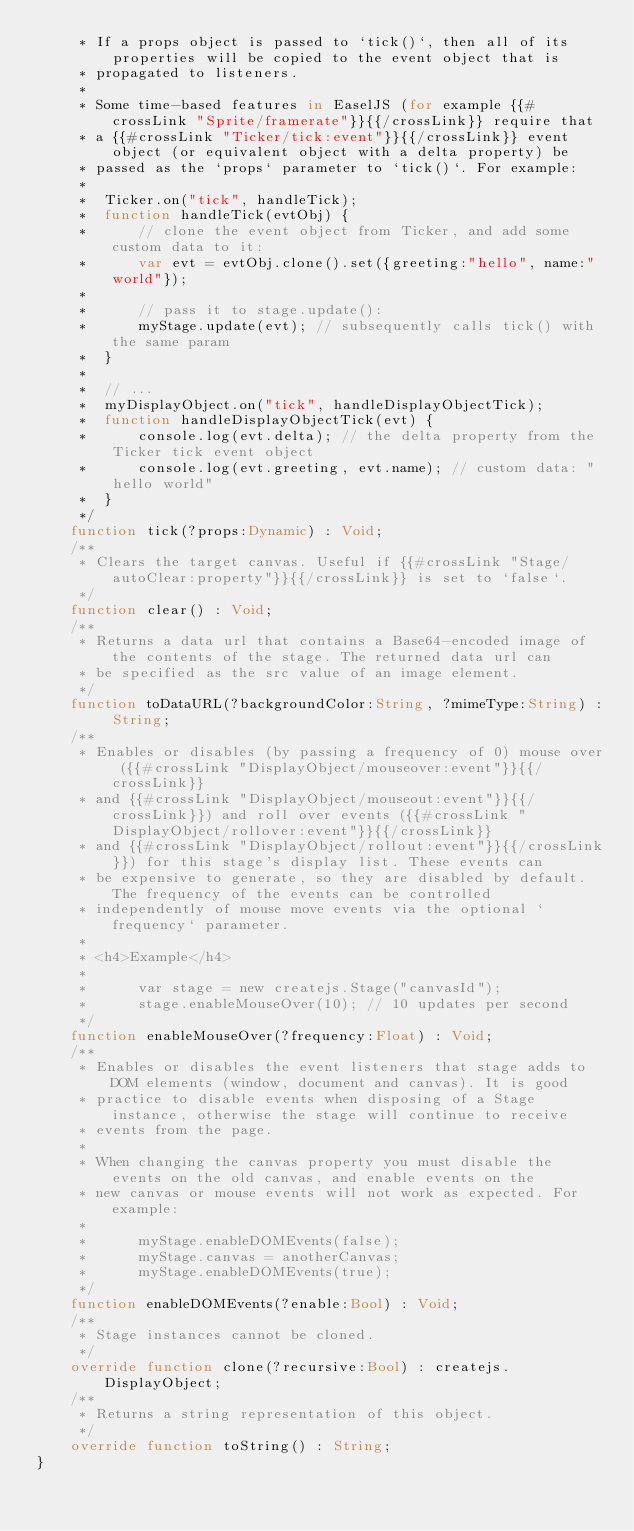<code> <loc_0><loc_0><loc_500><loc_500><_Haxe_>	 * If a props object is passed to `tick()`, then all of its properties will be copied to the event object that is
	 * propagated to listeners.
	 *
	 * Some time-based features in EaselJS (for example {{#crossLink "Sprite/framerate"}}{{/crossLink}} require that
	 * a {{#crossLink "Ticker/tick:event"}}{{/crossLink}} event object (or equivalent object with a delta property) be
	 * passed as the `props` parameter to `tick()`. For example:
	 *
	 * 	Ticker.on("tick", handleTick);
	 * 	function handleTick(evtObj) {
	 * 		// clone the event object from Ticker, and add some custom data to it:
	 * 		var evt = evtObj.clone().set({greeting:"hello", name:"world"});
	 *
	 * 		// pass it to stage.update():
	 * 		myStage.update(evt); // subsequently calls tick() with the same param
	 * 	}
	 *
	 * 	// ...
	 * 	myDisplayObject.on("tick", handleDisplayObjectTick);
	 * 	function handleDisplayObjectTick(evt) {
	 * 		console.log(evt.delta); // the delta property from the Ticker tick event object
	 * 		console.log(evt.greeting, evt.name); // custom data: "hello world"
	 * 	}
	 */
	function tick(?props:Dynamic) : Void;
	/**
	 * Clears the target canvas. Useful if {{#crossLink "Stage/autoClear:property"}}{{/crossLink}} is set to `false`.
	 */
	function clear() : Void;
	/**
	 * Returns a data url that contains a Base64-encoded image of the contents of the stage. The returned data url can
	 * be specified as the src value of an image element.
	 */
	function toDataURL(?backgroundColor:String, ?mimeType:String) : String;
	/**
	 * Enables or disables (by passing a frequency of 0) mouse over ({{#crossLink "DisplayObject/mouseover:event"}}{{/crossLink}}
	 * and {{#crossLink "DisplayObject/mouseout:event"}}{{/crossLink}}) and roll over events ({{#crossLink "DisplayObject/rollover:event"}}{{/crossLink}}
	 * and {{#crossLink "DisplayObject/rollout:event"}}{{/crossLink}}) for this stage's display list. These events can
	 * be expensive to generate, so they are disabled by default. The frequency of the events can be controlled
	 * independently of mouse move events via the optional `frequency` parameter.
	 *
	 * <h4>Example</h4>
	 *
	 *      var stage = new createjs.Stage("canvasId");
	 *      stage.enableMouseOver(10); // 10 updates per second
	 */
	function enableMouseOver(?frequency:Float) : Void;
	/**
	 * Enables or disables the event listeners that stage adds to DOM elements (window, document and canvas). It is good
	 * practice to disable events when disposing of a Stage instance, otherwise the stage will continue to receive
	 * events from the page.
	 *
	 * When changing the canvas property you must disable the events on the old canvas, and enable events on the
	 * new canvas or mouse events will not work as expected. For example:
	 *
	 *      myStage.enableDOMEvents(false);
	 *      myStage.canvas = anotherCanvas;
	 *      myStage.enableDOMEvents(true);
	 */
	function enableDOMEvents(?enable:Bool) : Void;
	/**
	 * Stage instances cannot be cloned.
	 */
	override function clone(?recursive:Bool) : createjs.DisplayObject;
	/**
	 * Returns a string representation of this object.
	 */
	override function toString() : String;
}</code> 